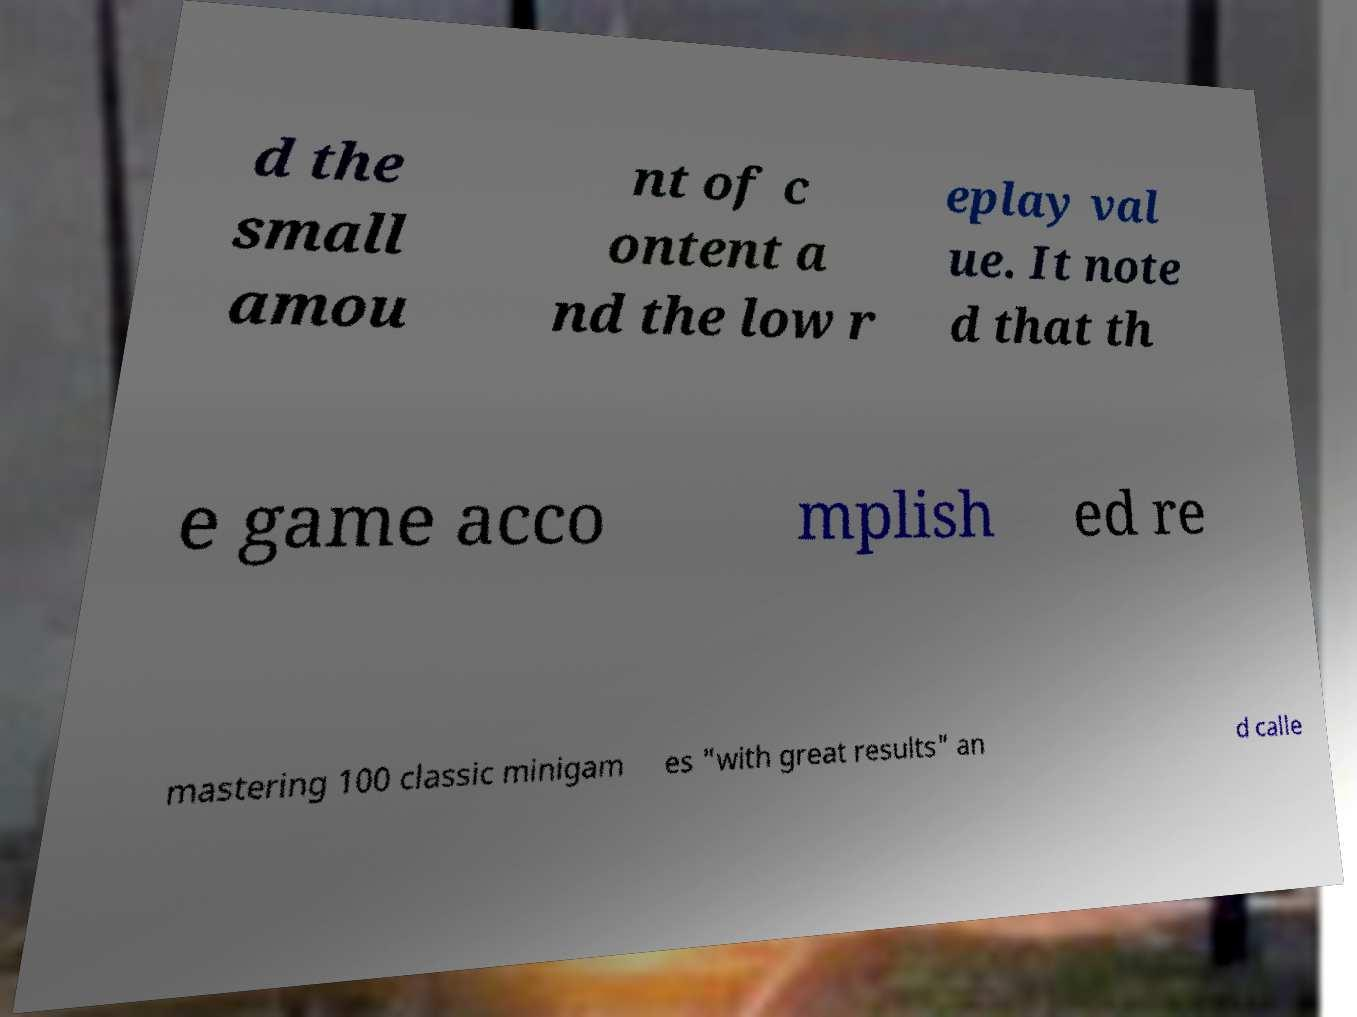There's text embedded in this image that I need extracted. Can you transcribe it verbatim? d the small amou nt of c ontent a nd the low r eplay val ue. It note d that th e game acco mplish ed re mastering 100 classic minigam es "with great results" an d calle 